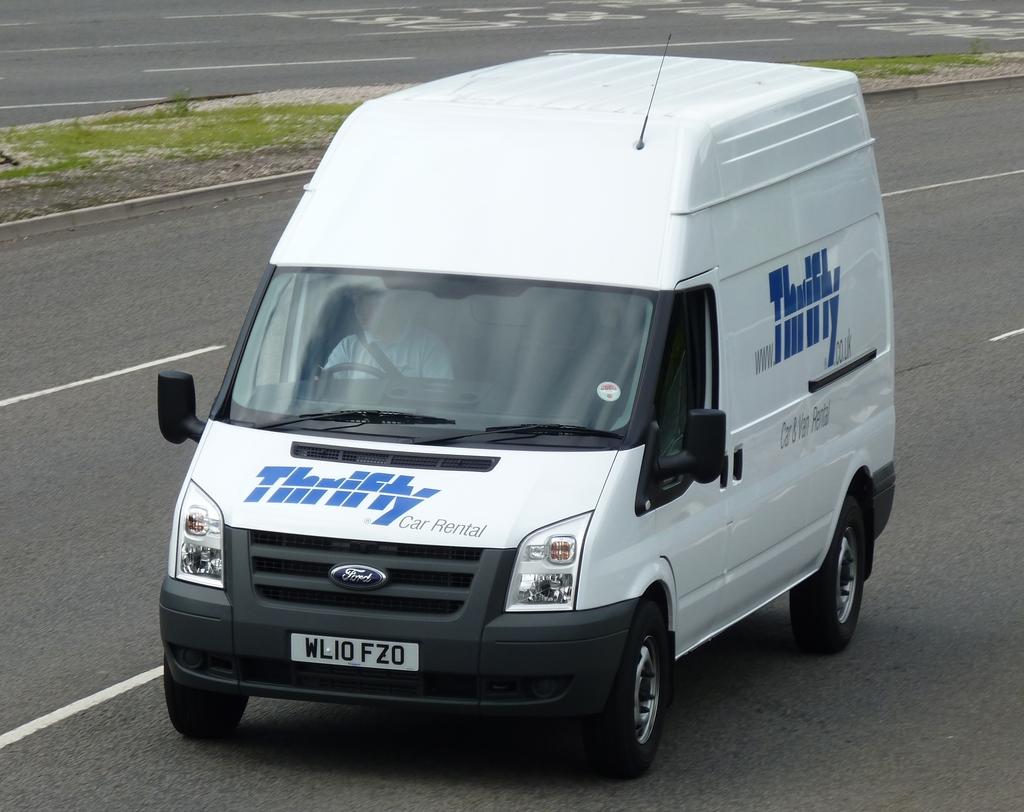What rental company is the van owned by?
Your answer should be very brief. Thrifty. What brand is the van?
Ensure brevity in your answer.  Thrifty. 